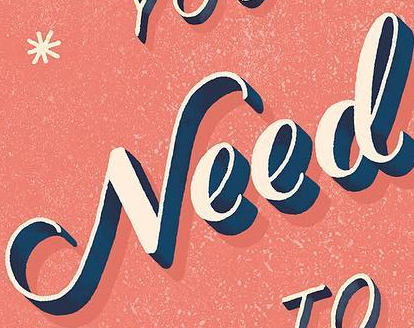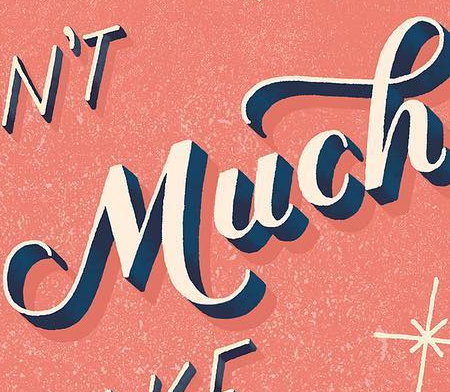Transcribe the words shown in these images in order, separated by a semicolon. Need; Much 